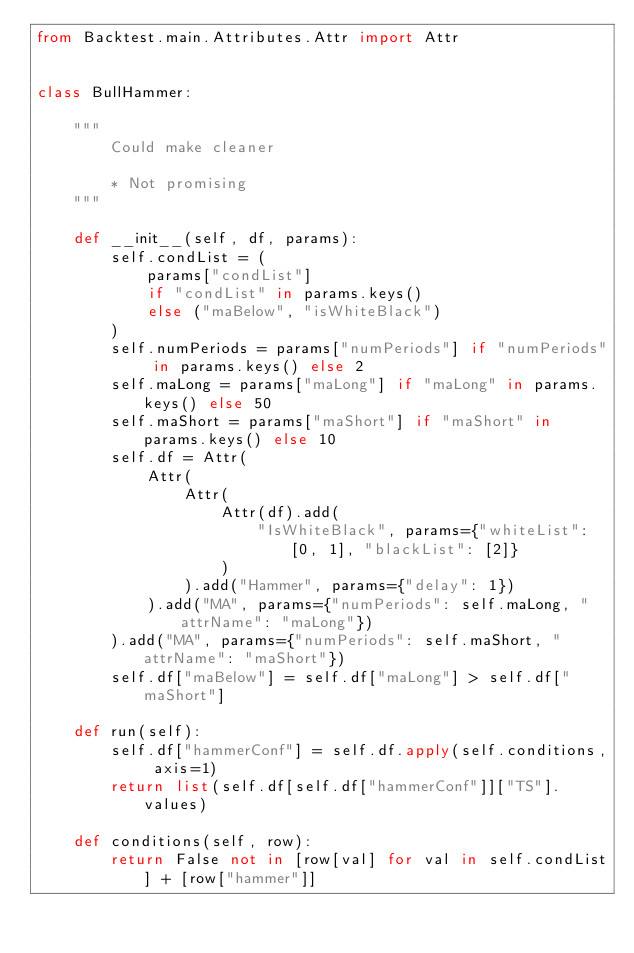<code> <loc_0><loc_0><loc_500><loc_500><_Python_>from Backtest.main.Attributes.Attr import Attr


class BullHammer:

    """
        Could make cleaner

        * Not promising
    """

    def __init__(self, df, params):
        self.condList = (
            params["condList"]
            if "condList" in params.keys()
            else ("maBelow", "isWhiteBlack")
        )
        self.numPeriods = params["numPeriods"] if "numPeriods" in params.keys() else 2
        self.maLong = params["maLong"] if "maLong" in params.keys() else 50
        self.maShort = params["maShort"] if "maShort" in params.keys() else 10
        self.df = Attr(
            Attr(
                Attr(
                    Attr(df).add(
                        "IsWhiteBlack", params={"whiteList": [0, 1], "blackList": [2]}
                    )
                ).add("Hammer", params={"delay": 1})
            ).add("MA", params={"numPeriods": self.maLong, "attrName": "maLong"})
        ).add("MA", params={"numPeriods": self.maShort, "attrName": "maShort"})
        self.df["maBelow"] = self.df["maLong"] > self.df["maShort"]

    def run(self):
        self.df["hammerConf"] = self.df.apply(self.conditions, axis=1)
        return list(self.df[self.df["hammerConf"]]["TS"].values)

    def conditions(self, row):
        return False not in [row[val] for val in self.condList] + [row["hammer"]]
</code> 